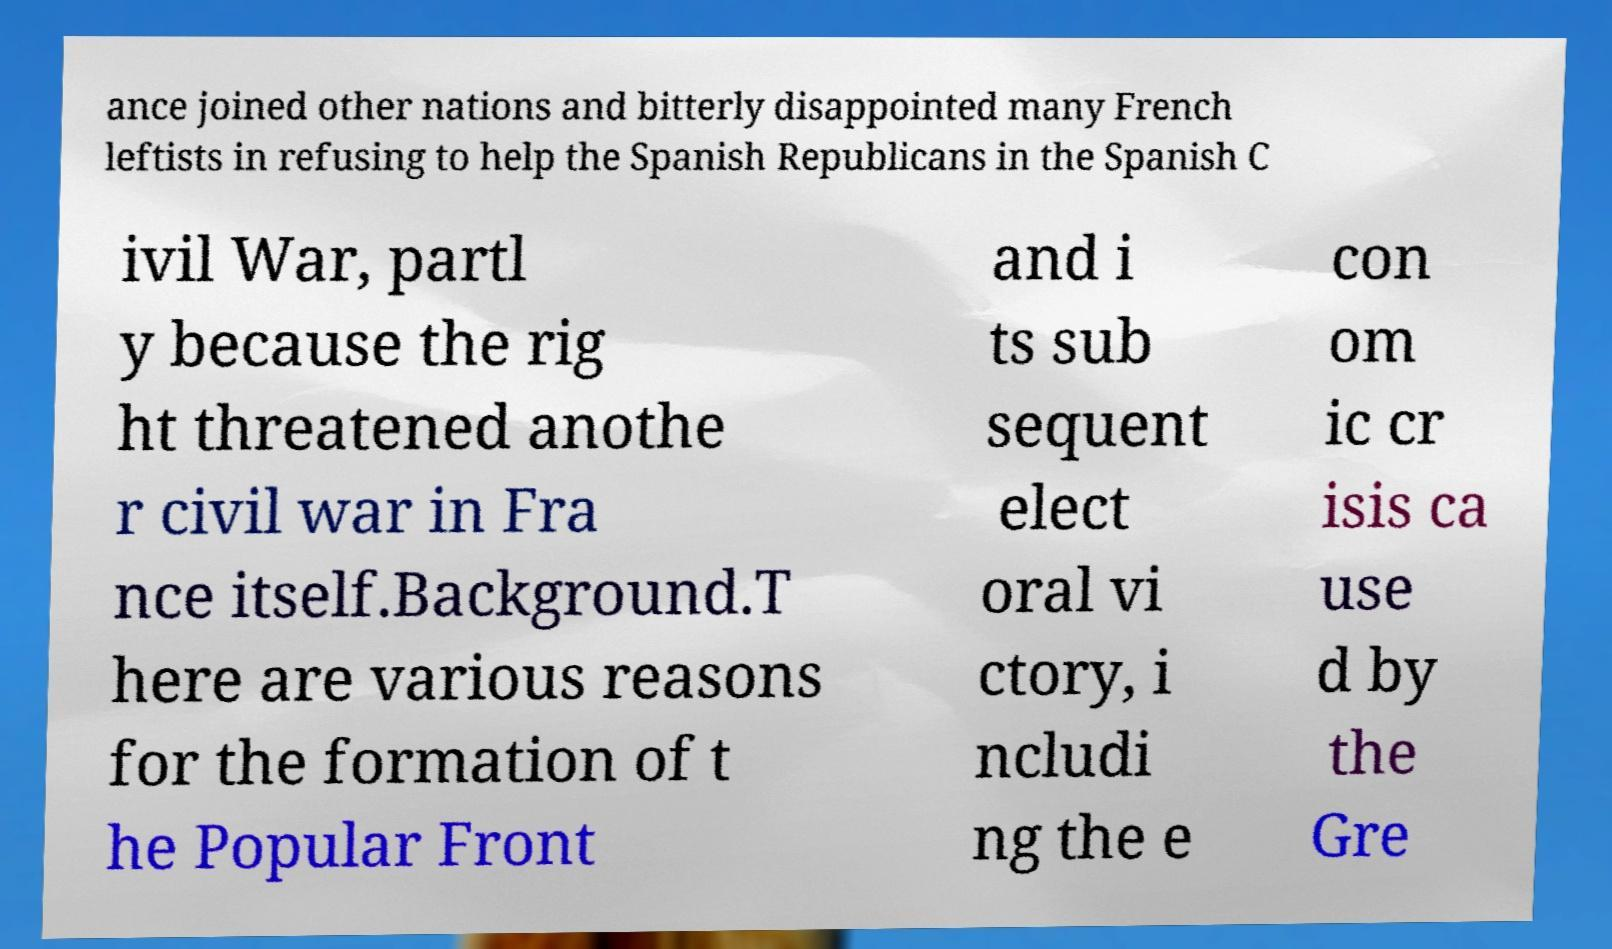What messages or text are displayed in this image? I need them in a readable, typed format. ance joined other nations and bitterly disappointed many French leftists in refusing to help the Spanish Republicans in the Spanish C ivil War, partl y because the rig ht threatened anothe r civil war in Fra nce itself.Background.T here are various reasons for the formation of t he Popular Front and i ts sub sequent elect oral vi ctory, i ncludi ng the e con om ic cr isis ca use d by the Gre 